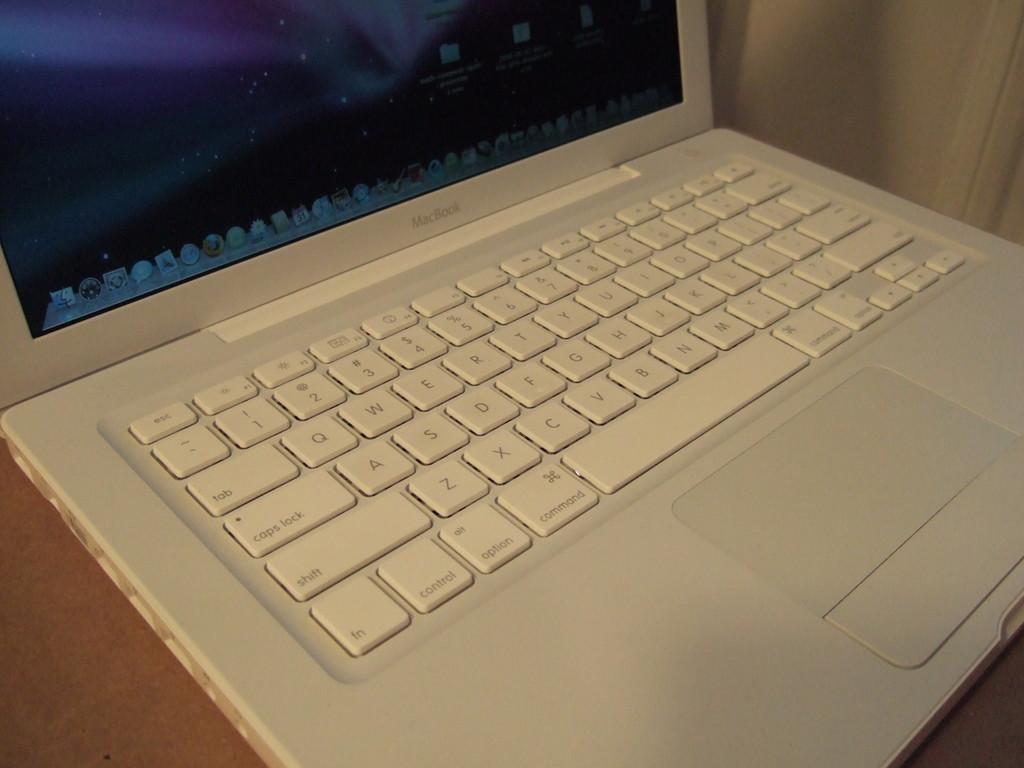Who makes this laptop?
Your answer should be compact. Macbook. 